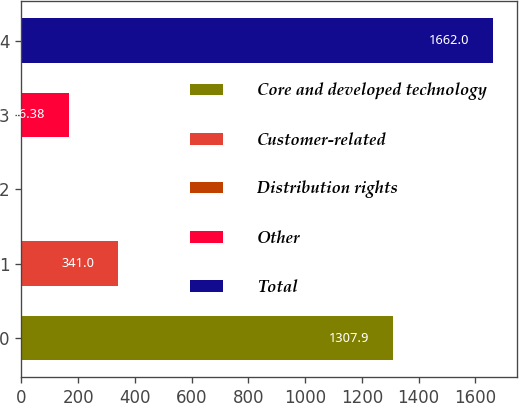Convert chart. <chart><loc_0><loc_0><loc_500><loc_500><bar_chart><fcel>Core and developed technology<fcel>Customer-related<fcel>Distribution rights<fcel>Other<fcel>Total<nl><fcel>1307.9<fcel>341<fcel>0.2<fcel>166.38<fcel>1662<nl></chart> 